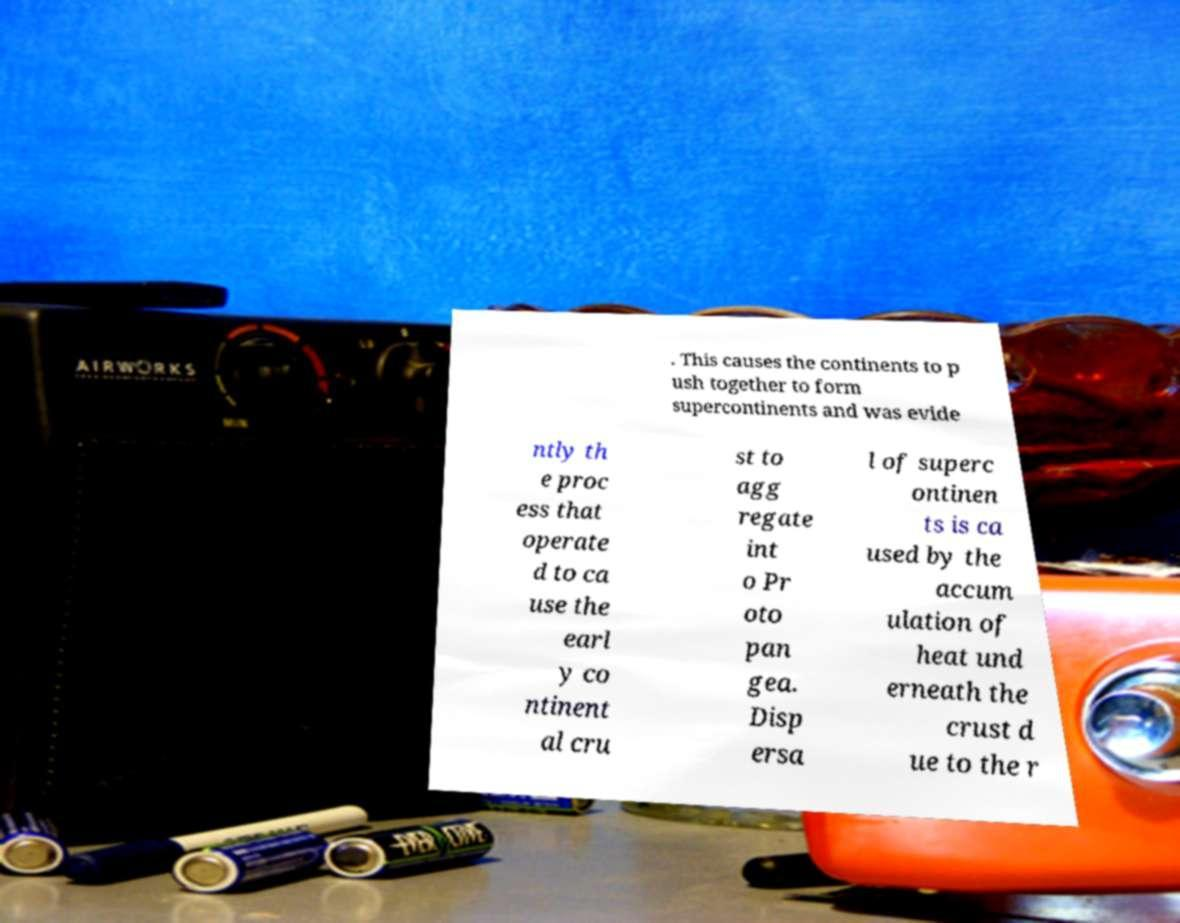There's text embedded in this image that I need extracted. Can you transcribe it verbatim? . This causes the continents to p ush together to form supercontinents and was evide ntly th e proc ess that operate d to ca use the earl y co ntinent al cru st to agg regate int o Pr oto pan gea. Disp ersa l of superc ontinen ts is ca used by the accum ulation of heat und erneath the crust d ue to the r 